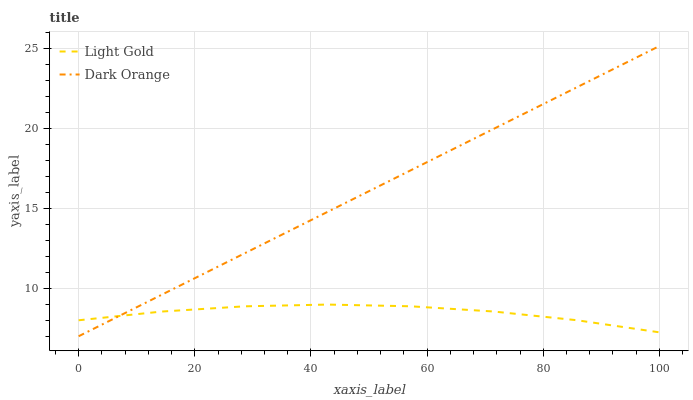Does Light Gold have the minimum area under the curve?
Answer yes or no. Yes. Does Dark Orange have the maximum area under the curve?
Answer yes or no. Yes. Does Light Gold have the maximum area under the curve?
Answer yes or no. No. Is Dark Orange the smoothest?
Answer yes or no. Yes. Is Light Gold the roughest?
Answer yes or no. Yes. Is Light Gold the smoothest?
Answer yes or no. No. Does Light Gold have the lowest value?
Answer yes or no. No. Does Dark Orange have the highest value?
Answer yes or no. Yes. Does Light Gold have the highest value?
Answer yes or no. No. Does Dark Orange intersect Light Gold?
Answer yes or no. Yes. Is Dark Orange less than Light Gold?
Answer yes or no. No. Is Dark Orange greater than Light Gold?
Answer yes or no. No. 